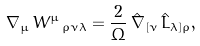<formula> <loc_0><loc_0><loc_500><loc_500>\nabla _ { \mu } \, W ^ { \mu } \, _ { \rho \nu \lambda } = \frac { 2 } { \Omega } \, \hat { \nabla } _ { [ \nu } \, \hat { L } _ { \lambda ] \rho } ,</formula> 